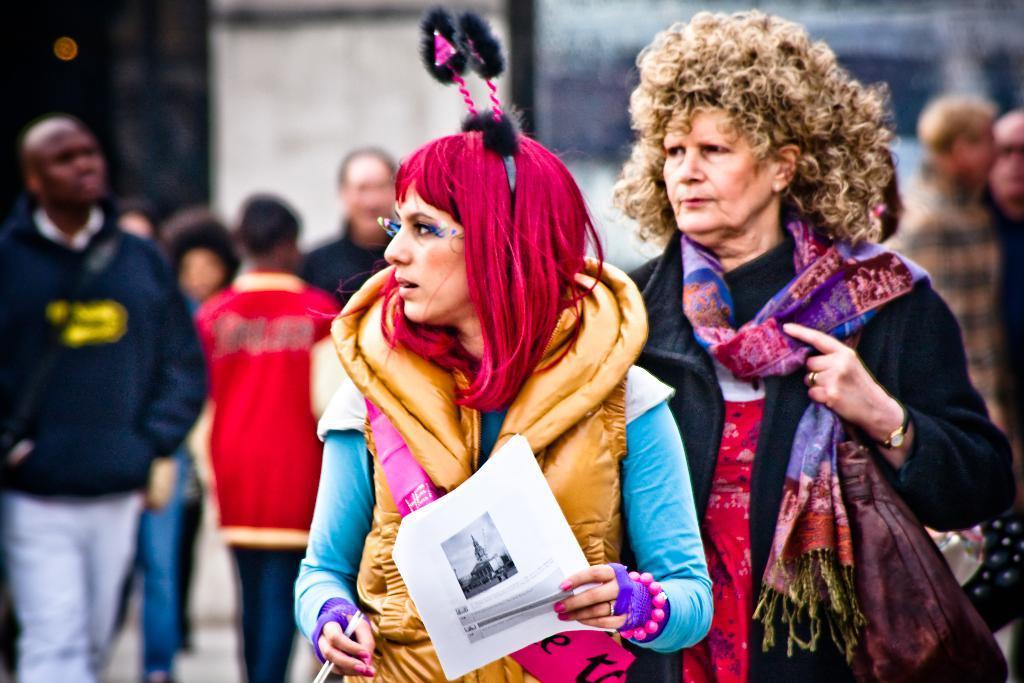In one or two sentences, can you explain what this image depicts? In this image, there is a person on the right side of the image wearing a bag. There is a person in the middle of the image holding a paper with her hand. There are some persons on the left side of the image standing and wearing clothes. 